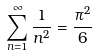<formula> <loc_0><loc_0><loc_500><loc_500>\sum _ { n = 1 } ^ { \infty } { \frac { 1 } { n ^ { 2 } } } = { \frac { \pi ^ { 2 } } { 6 } }</formula> 